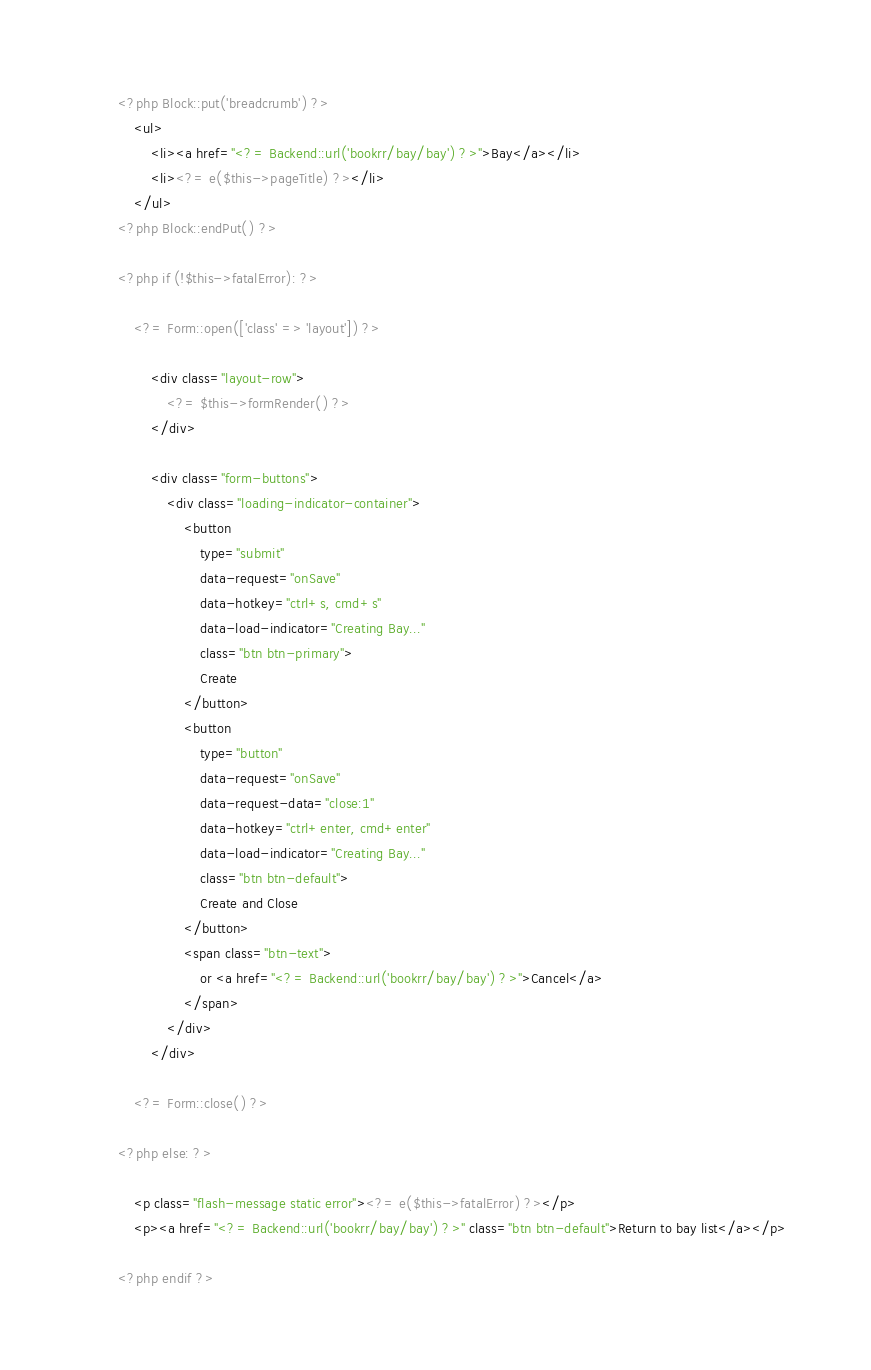<code> <loc_0><loc_0><loc_500><loc_500><_HTML_><?php Block::put('breadcrumb') ?>
    <ul>
        <li><a href="<?= Backend::url('bookrr/bay/bay') ?>">Bay</a></li>
        <li><?= e($this->pageTitle) ?></li>
    </ul>
<?php Block::endPut() ?>

<?php if (!$this->fatalError): ?>

    <?= Form::open(['class' => 'layout']) ?>

        <div class="layout-row">
            <?= $this->formRender() ?>
        </div>

        <div class="form-buttons">
            <div class="loading-indicator-container">
                <button
                    type="submit"
                    data-request="onSave"
                    data-hotkey="ctrl+s, cmd+s"
                    data-load-indicator="Creating Bay..."
                    class="btn btn-primary">
                    Create
                </button>
                <button
                    type="button"
                    data-request="onSave"
                    data-request-data="close:1"
                    data-hotkey="ctrl+enter, cmd+enter"
                    data-load-indicator="Creating Bay..."
                    class="btn btn-default">
                    Create and Close
                </button>
                <span class="btn-text">
                    or <a href="<?= Backend::url('bookrr/bay/bay') ?>">Cancel</a>
                </span>
            </div>
        </div>

    <?= Form::close() ?>

<?php else: ?>

    <p class="flash-message static error"><?= e($this->fatalError) ?></p>
    <p><a href="<?= Backend::url('bookrr/bay/bay') ?>" class="btn btn-default">Return to bay list</a></p>

<?php endif ?>
</code> 